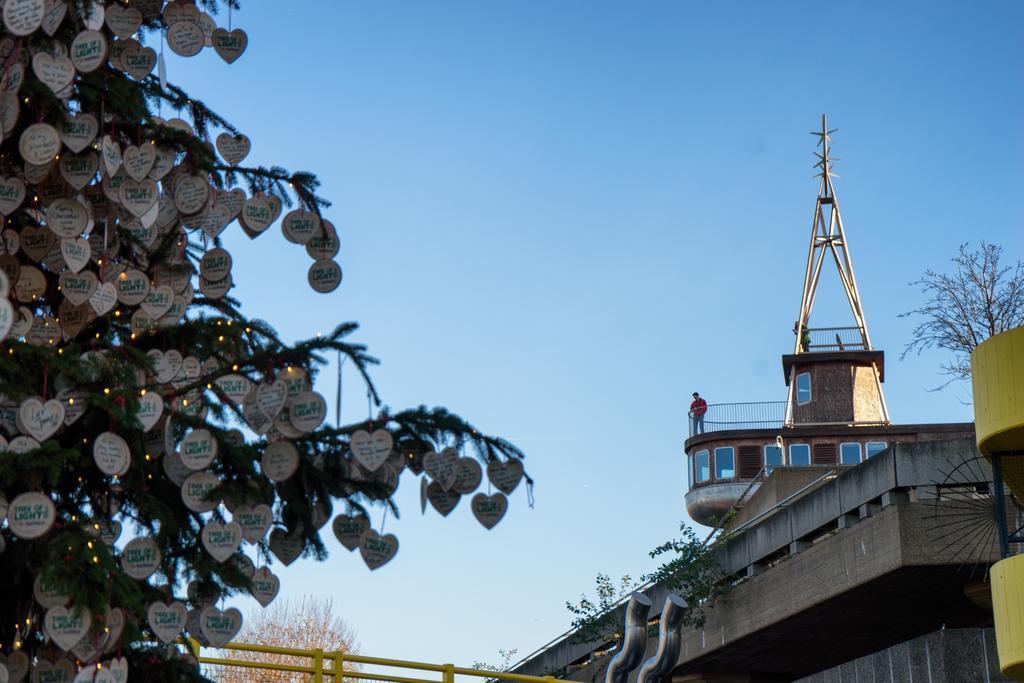Can you describe this image briefly? In this image there is a building on the right side, on the top of the building there is the person, behind the building there is a tree, at the top there is the sky, on the left side there is a Christmas tree decorated with lights, may be greeting cards. 